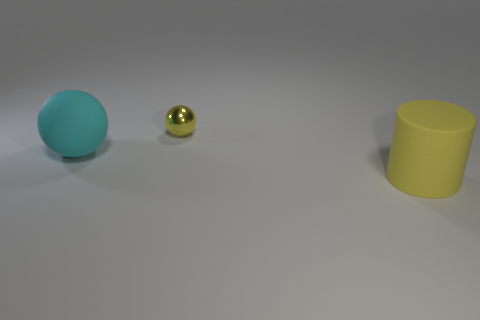Add 3 yellow matte cylinders. How many objects exist? 6 Subtract all spheres. How many objects are left? 1 Add 1 small metallic things. How many small metallic things exist? 2 Subtract 0 gray blocks. How many objects are left? 3 Subtract all cylinders. Subtract all tiny shiny things. How many objects are left? 1 Add 1 small yellow metallic things. How many small yellow metallic things are left? 2 